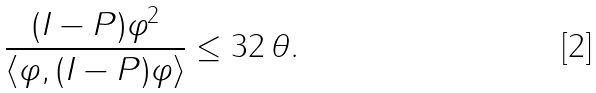Convert formula to latex. <formula><loc_0><loc_0><loc_500><loc_500>\frac { \| ( I - P ) \varphi \| ^ { 2 } } { \langle \varphi , ( I - P ) \varphi \rangle } \leq 3 2 \, \theta .</formula> 